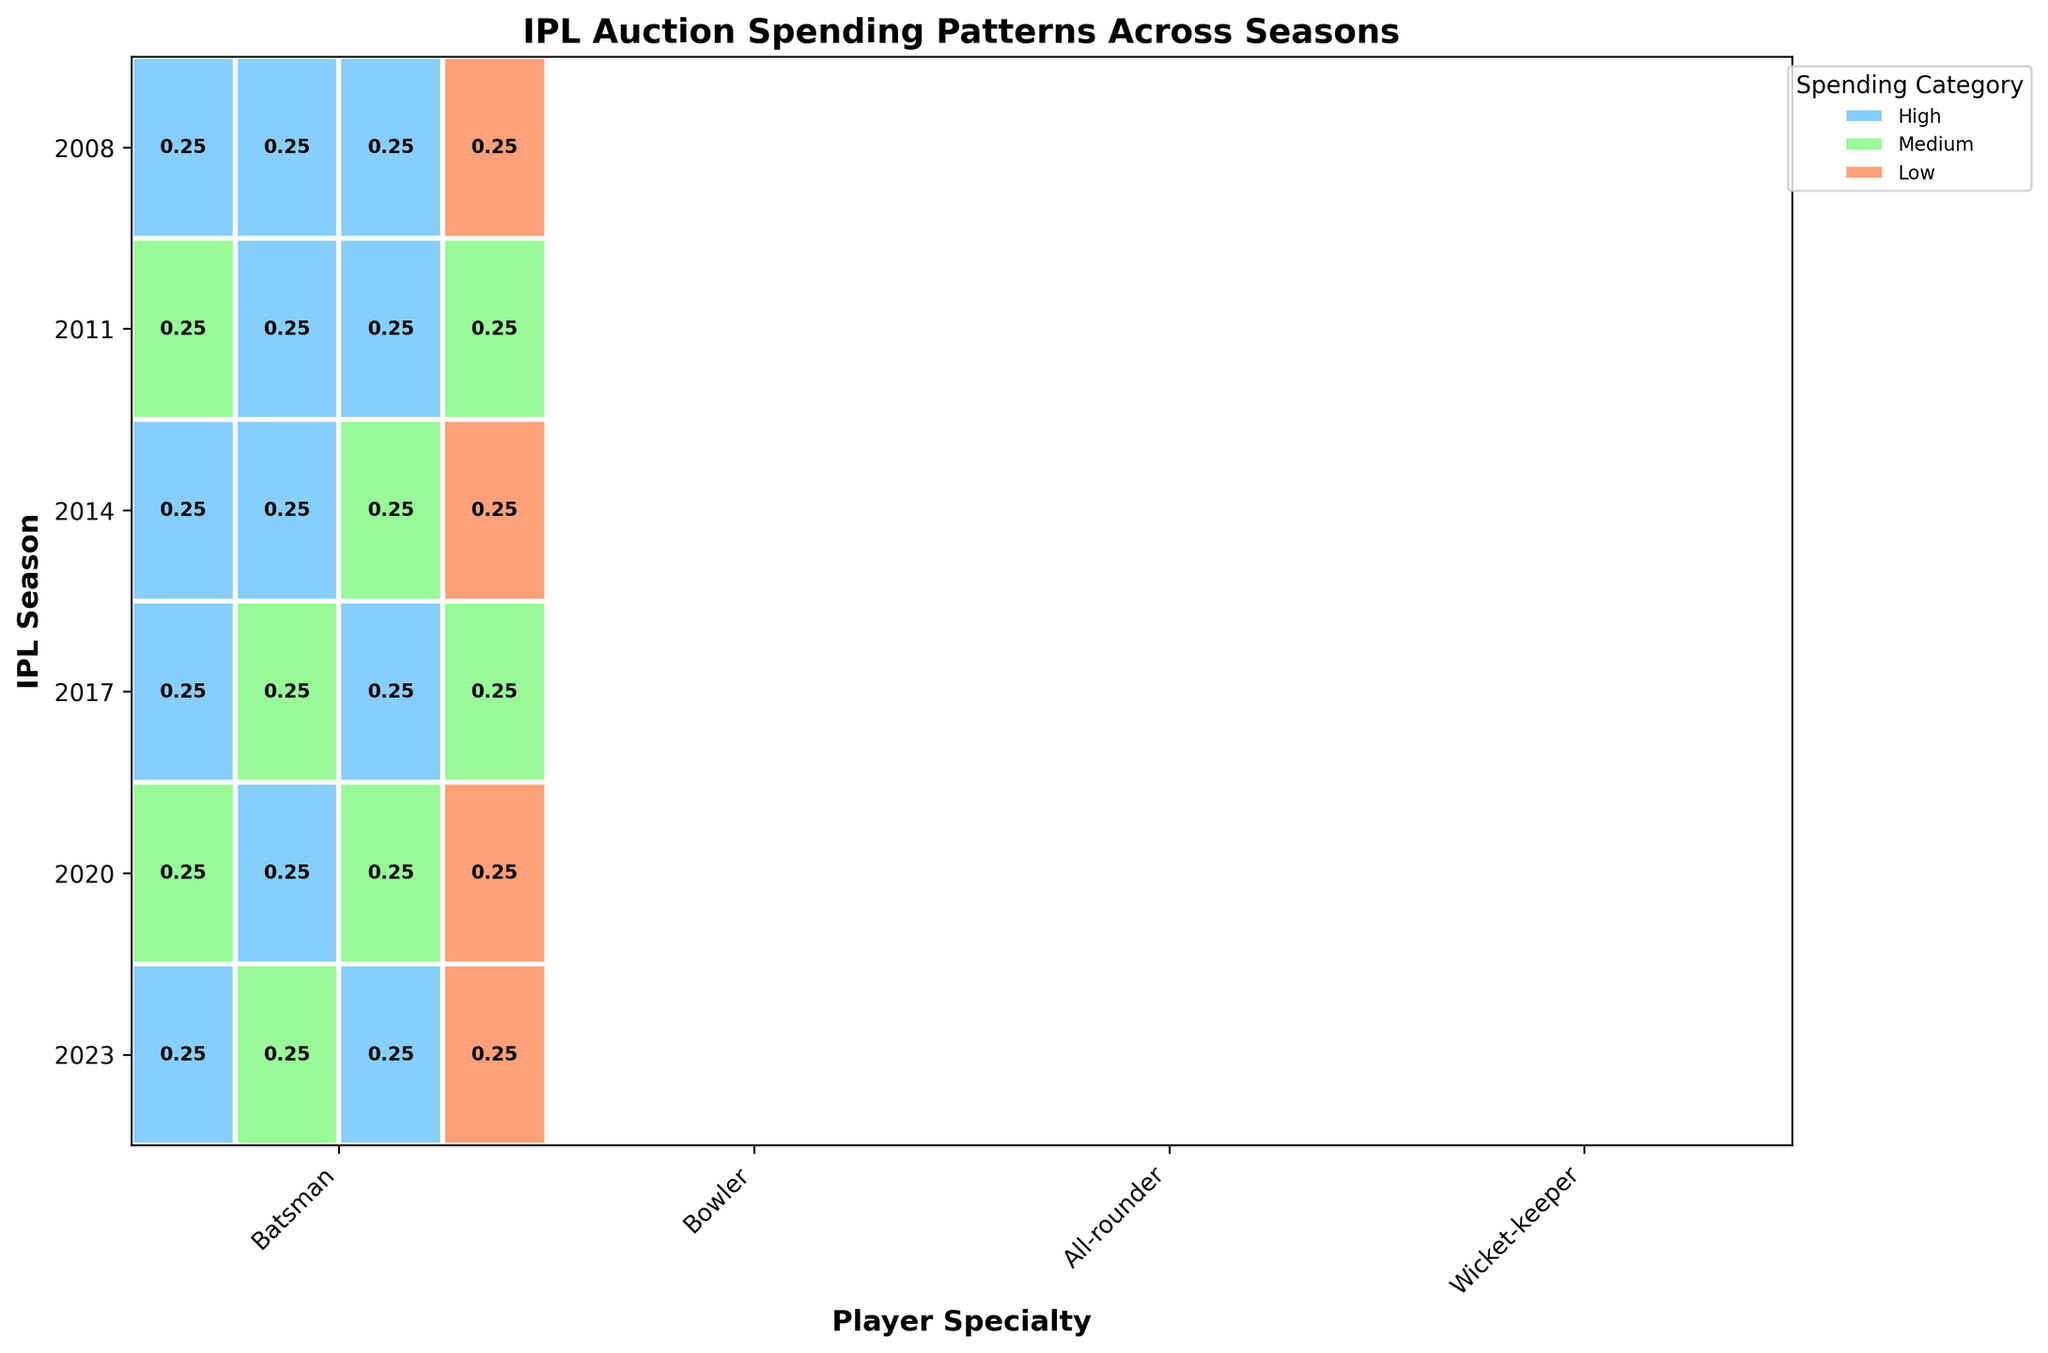What title is displayed at the top of the mosaic plot? The title is found prominently above the plot and typically describes the overall subject of the visualization. In this case, the title given is "IPL Auction Spending Patterns Across Seasons".
Answer: IPL Auction Spending Patterns Across Seasons Which player specialty had the highest spending category in the 2023 season? To find this, look at the row corresponding to the 2023 season and identify the specialty with the largest portion of the plot segment colored blue (indicating High spending). The "Bowler," "Batsman," and "All-rounder" specialties had high spending categories.
Answer: Batsman, Bowler, All-rounder What spending category occurred the least frequently across all seasons? This requires observing the entire plot and determining which color is represented the least. The corresponding legend will indicate which spending category this color represents. The orange color, representing the "Low" spending category, appears the least frequently.
Answer: Low In which season(s) did wicket-keepers not have a medium spending category? Look through each season's Wicket-keeper specialty and check if "Medium" spending (represented by green) is absent. The seasons 2008, 2011, 2017, and 2023 do not show "Medium" spending for wicket-keepers.
Answer: 2008, 2011, 2017, 2023 How many specialties had 'High' spending in the 2017 season? The 2017 row can be checked for each specialized segment. Counting the segments with blue (high spending), it can be determined that two specialties (Batsman and Bowler) had high spending in 2017.
Answer: Two What specialty shows the highest variation in spending categories across all seasons? To determine this, observe each specialty across all seasons and identify which one showcases a range of different spending categories (Low, Medium, High). The specialty "Wicket-keeper" shows all three spending categories across different seasons.
Answer: Wicket-keeper Compare the spending on bowlers in 2008 and 2020. Which season had higher spending? Observe the portions of the Bowler category row for blue (high spending) in both 2008 and 2020. In 2020, the spending is high (blue), while 2008 is medium (green). Thus, 2020 had higher spending.
Answer: 2020 In which season did all player specialties have at least medium spending? Scan each season's row and ensure every specialty has at least green (medium spending). For 2014 and 2020, every specialty had medium or high spending categories.
Answer: 2014, 2020 